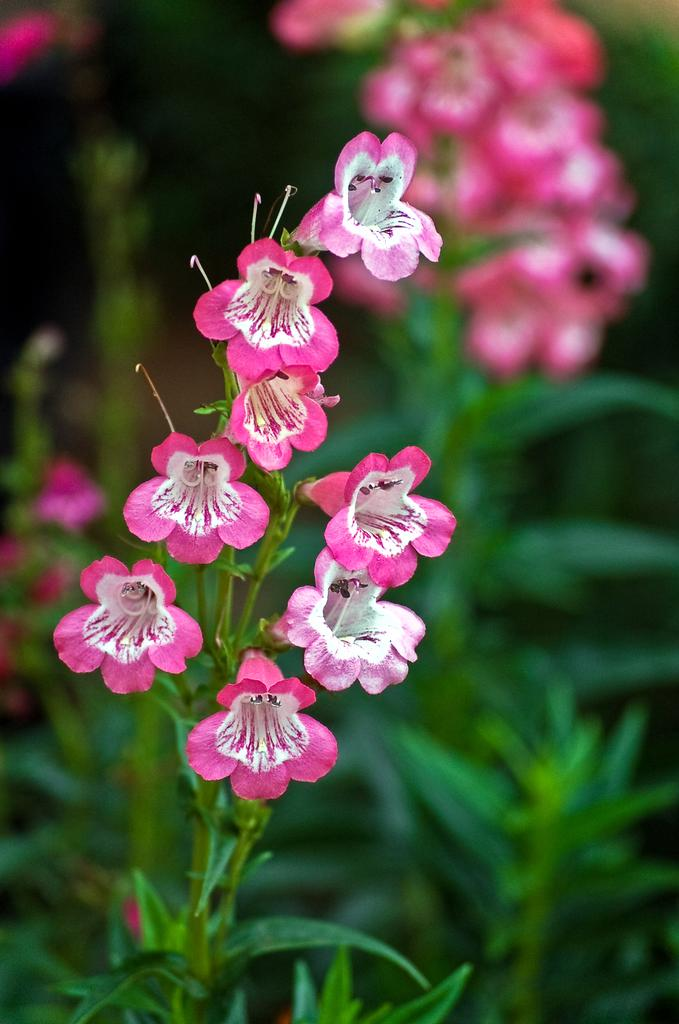What types of plants can be seen in the image? There are flowers and plants in the image. Can you describe the background of the image? The background of the image is blurred. What type of afterthought is visible on the stage in the image? There is no stage or afterthought present in the image; it features flowers and plants with a blurred background. 